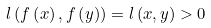<formula> <loc_0><loc_0><loc_500><loc_500>l \left ( f \left ( x \right ) , f \left ( y \right ) \right ) = l \left ( x , y \right ) > 0</formula> 